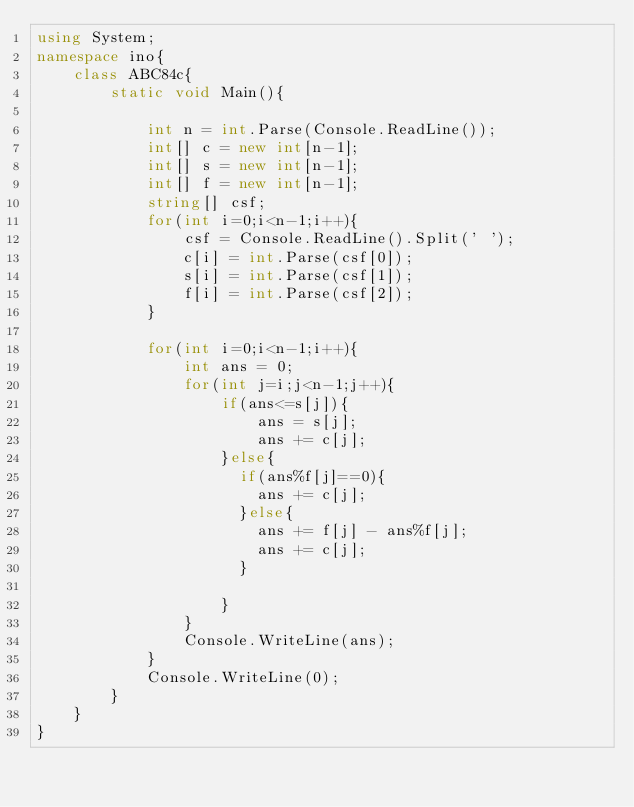<code> <loc_0><loc_0><loc_500><loc_500><_C#_>using System;
namespace ino{
    class ABC84c{
        static void Main(){

            int n = int.Parse(Console.ReadLine());
            int[] c = new int[n-1];
            int[] s = new int[n-1];
            int[] f = new int[n-1];
            string[] csf;
            for(int i=0;i<n-1;i++){
                csf = Console.ReadLine().Split(' ');
                c[i] = int.Parse(csf[0]);
                s[i] = int.Parse(csf[1]);
                f[i] = int.Parse(csf[2]);
            }

            for(int i=0;i<n-1;i++){
                int ans = 0;
                for(int j=i;j<n-1;j++){
                    if(ans<=s[j]){
                        ans = s[j];
                        ans += c[j];
                    }else{
                      if(ans%f[j]==0){
                        ans += c[j];
                      }else{
                        ans += f[j] - ans%f[j];
                        ans += c[j];
                      }
                        
                    }
                }
                Console.WriteLine(ans);
            }
            Console.WriteLine(0);
        }
    }
}</code> 